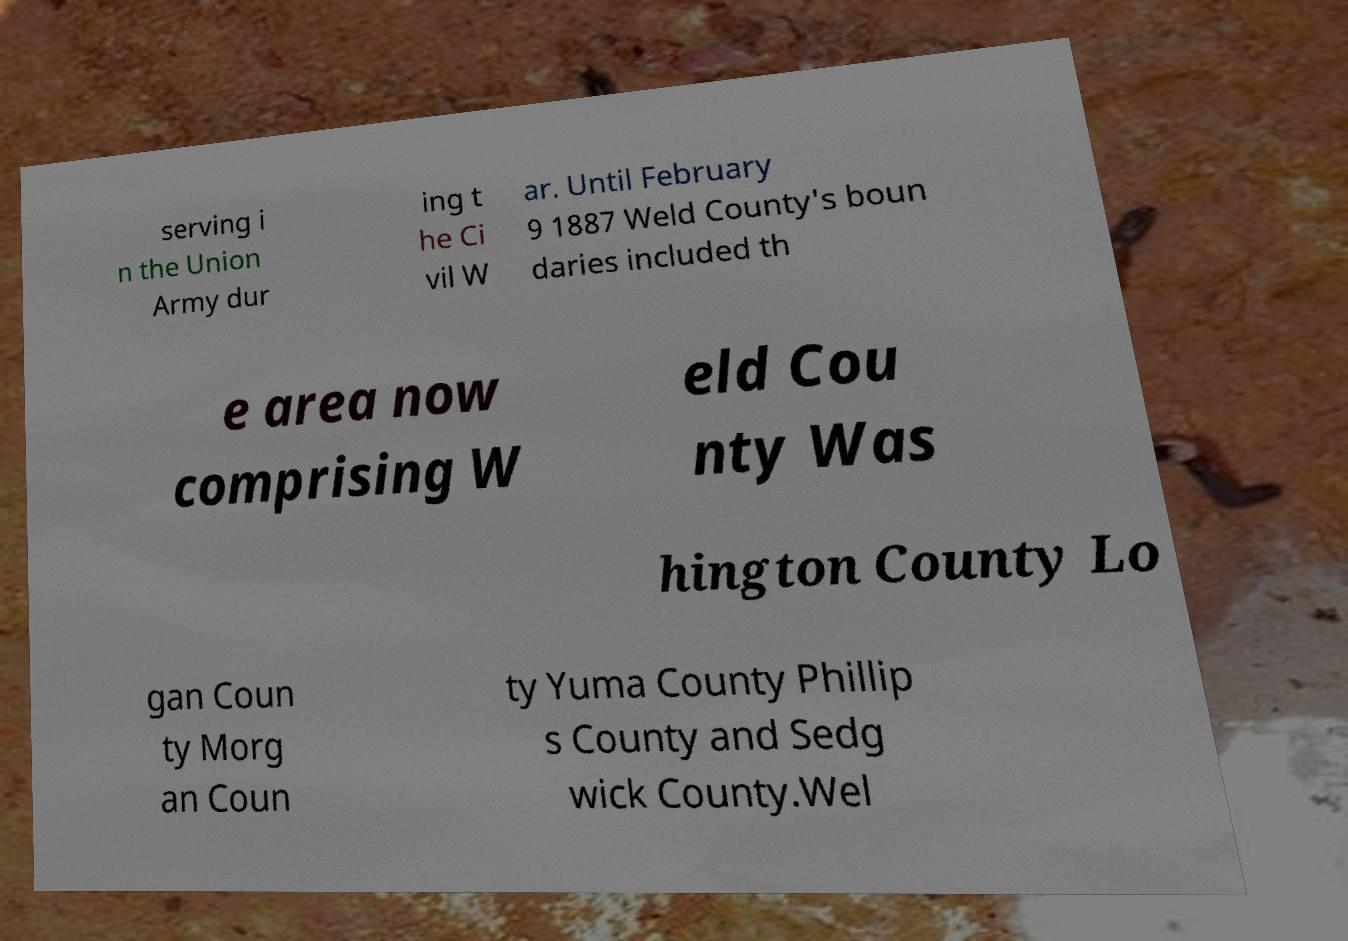There's text embedded in this image that I need extracted. Can you transcribe it verbatim? serving i n the Union Army dur ing t he Ci vil W ar. Until February 9 1887 Weld County's boun daries included th e area now comprising W eld Cou nty Was hington County Lo gan Coun ty Morg an Coun ty Yuma County Phillip s County and Sedg wick County.Wel 